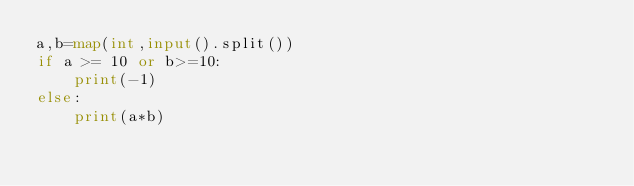<code> <loc_0><loc_0><loc_500><loc_500><_Python_>a,b=map(int,input().split())
if a >= 10 or b>=10:
    print(-1)
else:
    print(a*b)</code> 